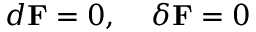Convert formula to latex. <formula><loc_0><loc_0><loc_500><loc_500>d { F } = 0 , \, \delta { F } = 0</formula> 